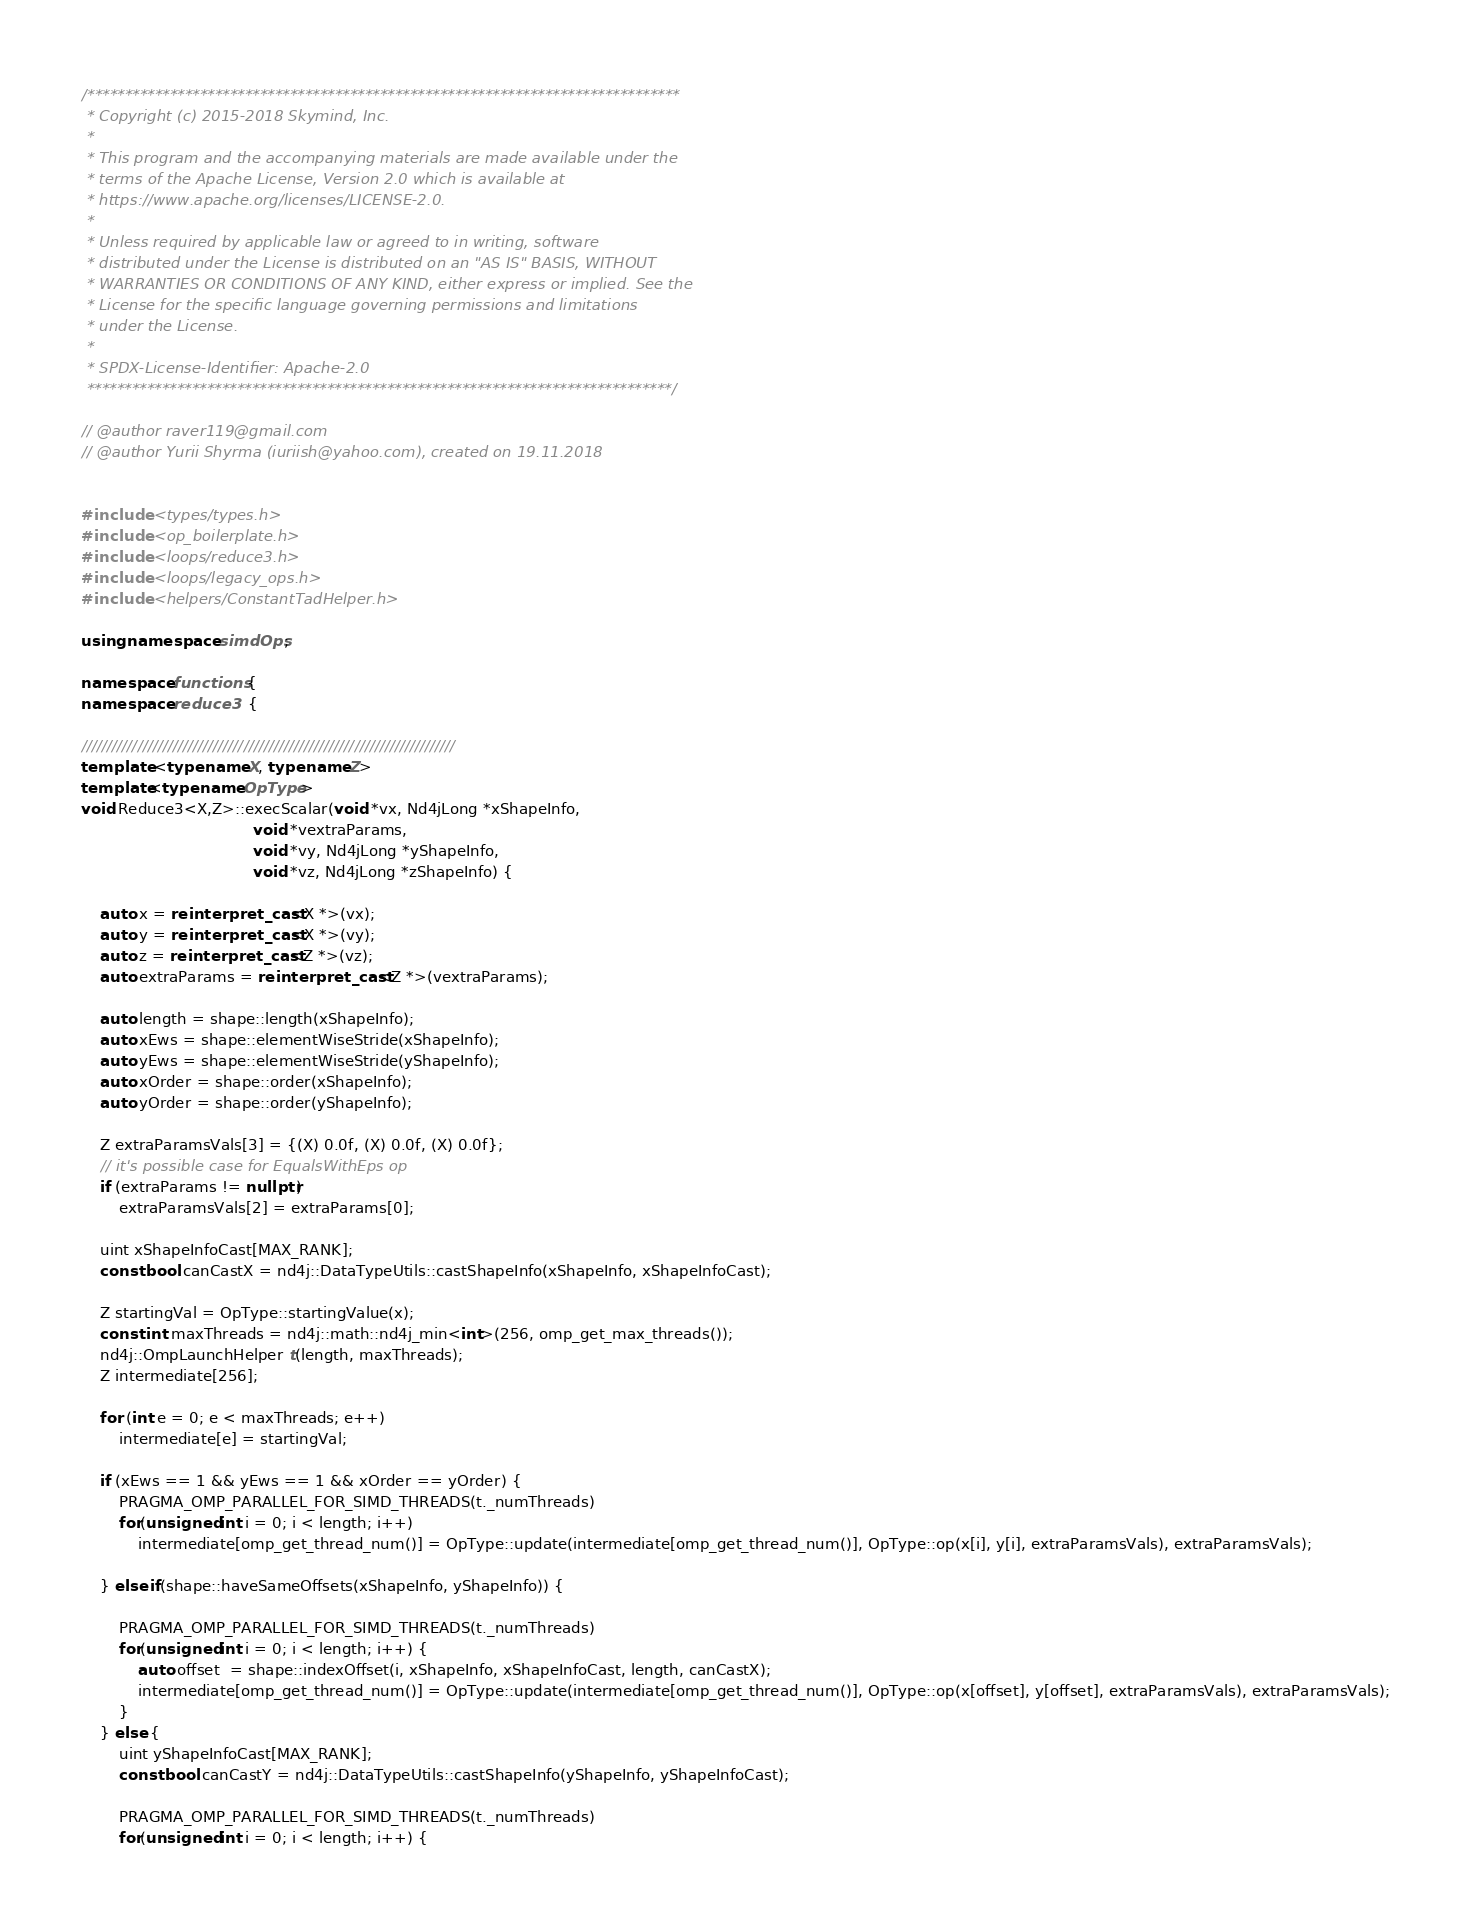<code> <loc_0><loc_0><loc_500><loc_500><_C++_>/*******************************************************************************
 * Copyright (c) 2015-2018 Skymind, Inc.
 *
 * This program and the accompanying materials are made available under the
 * terms of the Apache License, Version 2.0 which is available at
 * https://www.apache.org/licenses/LICENSE-2.0.
 *
 * Unless required by applicable law or agreed to in writing, software
 * distributed under the License is distributed on an "AS IS" BASIS, WITHOUT
 * WARRANTIES OR CONDITIONS OF ANY KIND, either express or implied. See the
 * License for the specific language governing permissions and limitations
 * under the License.
 *
 * SPDX-License-Identifier: Apache-2.0
 ******************************************************************************/

// @author raver119@gmail.com
// @author Yurii Shyrma (iuriish@yahoo.com), created on 19.11.2018


#include <types/types.h>
#include <op_boilerplate.h>
#include <loops/reduce3.h>
#include <loops/legacy_ops.h>
#include <helpers/ConstantTadHelper.h>

using namespace simdOps;

namespace functions {
namespace reduce3   {

//////////////////////////////////////////////////////////////////////////
template <typename X, typename Z>
template<typename OpType>
void Reduce3<X,Z>::execScalar(void *vx, Nd4jLong *xShapeInfo,
                                    void *vextraParams,
                                    void *vy, Nd4jLong *yShapeInfo,
                                    void *vz, Nd4jLong *zShapeInfo) {
    
    auto x = reinterpret_cast<X *>(vx);
    auto y = reinterpret_cast<X *>(vy);
    auto z = reinterpret_cast<Z *>(vz);
    auto extraParams = reinterpret_cast<Z *>(vextraParams);

    auto length = shape::length(xShapeInfo);
    auto xEws = shape::elementWiseStride(xShapeInfo);
    auto yEws = shape::elementWiseStride(yShapeInfo);
    auto xOrder = shape::order(xShapeInfo);
    auto yOrder = shape::order(yShapeInfo);

    Z extraParamsVals[3] = {(X) 0.0f, (X) 0.0f, (X) 0.0f};
    // it's possible case for EqualsWithEps op
    if (extraParams != nullptr) 
        extraParamsVals[2] = extraParams[0];                
    
    uint xShapeInfoCast[MAX_RANK];
    const bool canCastX = nd4j::DataTypeUtils::castShapeInfo(xShapeInfo, xShapeInfoCast);

    Z startingVal = OpType::startingValue(x);
    const int maxThreads = nd4j::math::nd4j_min<int>(256, omp_get_max_threads());
    nd4j::OmpLaunchHelper t(length, maxThreads);
    Z intermediate[256];

    for (int e = 0; e < maxThreads; e++)
        intermediate[e] = startingVal;

    if (xEws == 1 && yEws == 1 && xOrder == yOrder) {
        PRAGMA_OMP_PARALLEL_FOR_SIMD_THREADS(t._numThreads)
        for(unsigned int i = 0; i < length; i++)
            intermediate[omp_get_thread_num()] = OpType::update(intermediate[omp_get_thread_num()], OpType::op(x[i], y[i], extraParamsVals), extraParamsVals);

    } else if(shape::haveSameOffsets(xShapeInfo, yShapeInfo)) {

        PRAGMA_OMP_PARALLEL_FOR_SIMD_THREADS(t._numThreads)
        for(unsigned int i = 0; i < length; i++) {            
            auto offset  = shape::indexOffset(i, xShapeInfo, xShapeInfoCast, length, canCastX);
            intermediate[omp_get_thread_num()] = OpType::update(intermediate[omp_get_thread_num()], OpType::op(x[offset], y[offset], extraParamsVals), extraParamsVals);
        }
    } else {
        uint yShapeInfoCast[MAX_RANK];
        const bool canCastY = nd4j::DataTypeUtils::castShapeInfo(yShapeInfo, yShapeInfoCast);

        PRAGMA_OMP_PARALLEL_FOR_SIMD_THREADS(t._numThreads)
        for(unsigned int i = 0; i < length; i++) {            </code> 